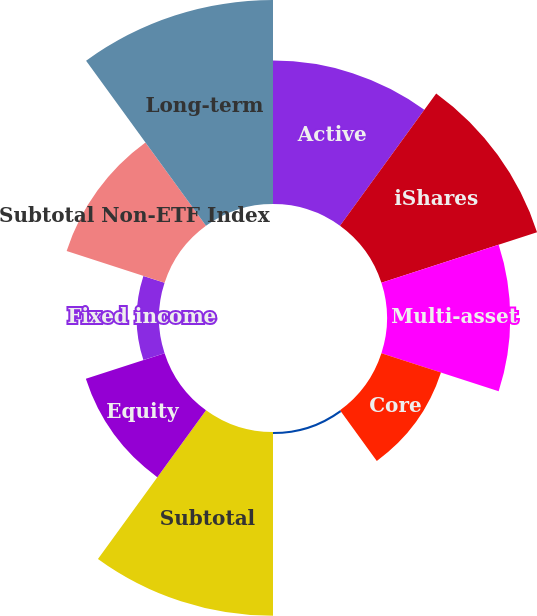<chart> <loc_0><loc_0><loc_500><loc_500><pie_chart><fcel>Active<fcel>iShares<fcel>Multi-asset<fcel>Core<fcel>Currency and commodities<fcel>Subtotal<fcel>Equity<fcel>Fixed income<fcel>Subtotal Non-ETF Index<fcel>Long-term<nl><fcel>13.15%<fcel>15.0%<fcel>11.3%<fcel>5.74%<fcel>0.19%<fcel>16.85%<fcel>7.59%<fcel>2.04%<fcel>9.44%<fcel>18.7%<nl></chart> 